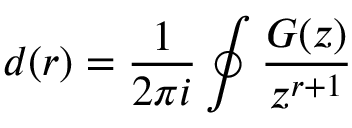<formula> <loc_0><loc_0><loc_500><loc_500>d ( r ) = \frac { 1 } { 2 \pi i } \oint \frac { G ( z ) } { z ^ { r + 1 } }</formula> 